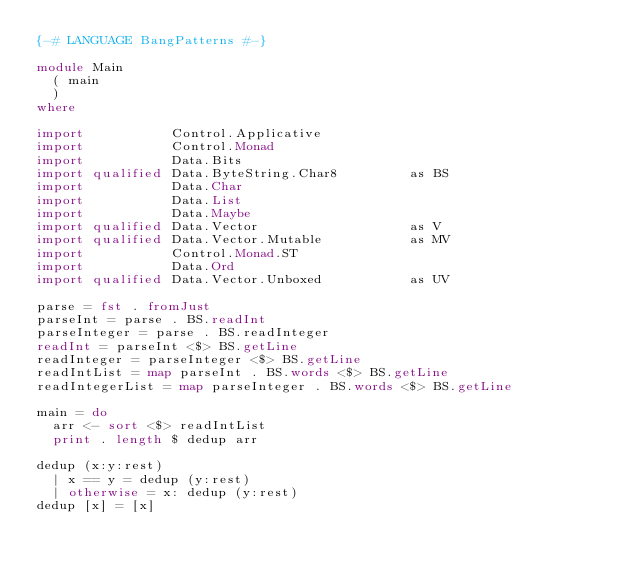Convert code to text. <code><loc_0><loc_0><loc_500><loc_500><_Haskell_>{-# LANGUAGE BangPatterns #-}

module Main
  ( main
  )
where

import           Control.Applicative
import           Control.Monad
import           Data.Bits
import qualified Data.ByteString.Char8         as BS
import           Data.Char
import           Data.List
import           Data.Maybe
import qualified Data.Vector                   as V
import qualified Data.Vector.Mutable           as MV
import           Control.Monad.ST
import           Data.Ord
import qualified Data.Vector.Unboxed           as UV

parse = fst . fromJust
parseInt = parse . BS.readInt
parseInteger = parse . BS.readInteger
readInt = parseInt <$> BS.getLine
readInteger = parseInteger <$> BS.getLine
readIntList = map parseInt . BS.words <$> BS.getLine
readIntegerList = map parseInteger . BS.words <$> BS.getLine

main = do
  arr <- sort <$> readIntList
  print . length $ dedup arr

dedup (x:y:rest)
  | x == y = dedup (y:rest)
  | otherwise = x: dedup (y:rest)
dedup [x] = [x]
</code> 